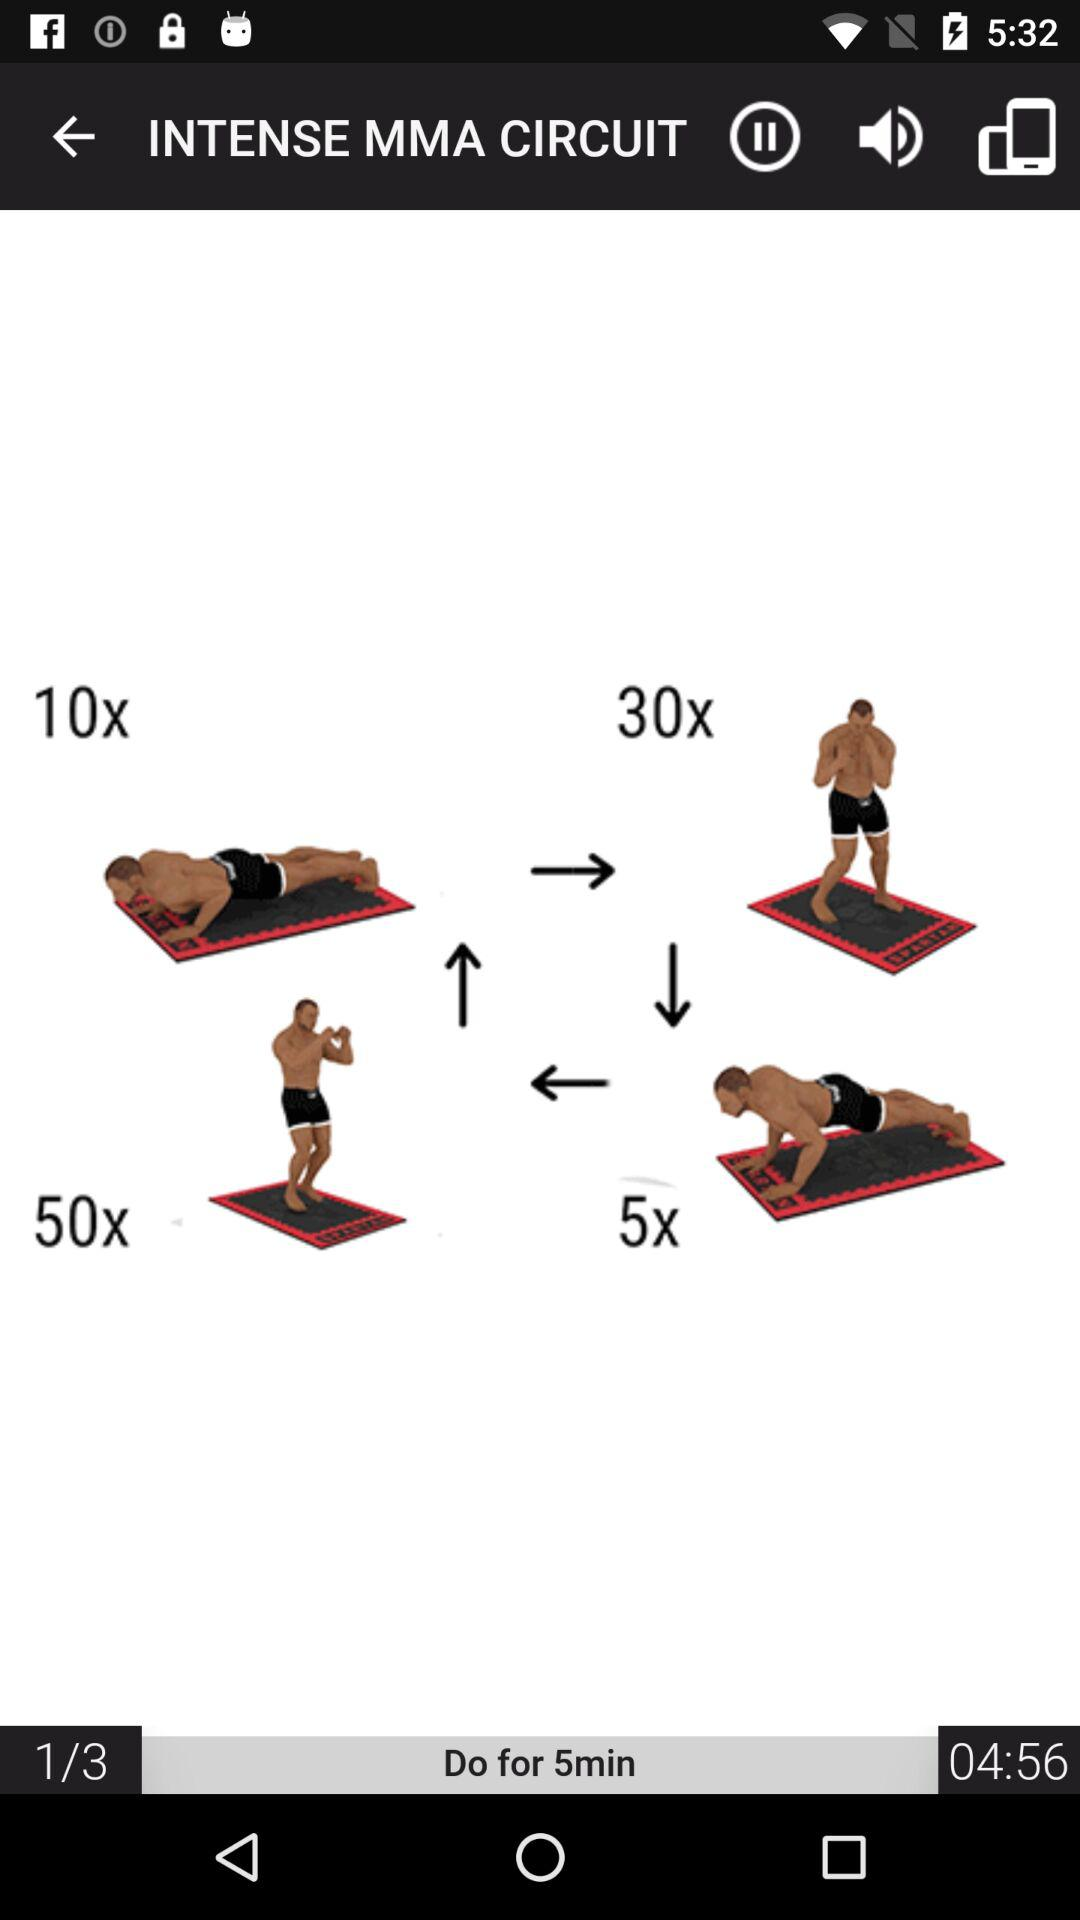How many more repetitions are there for 30x than 10x?
Answer the question using a single word or phrase. 20 